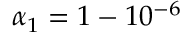<formula> <loc_0><loc_0><loc_500><loc_500>\alpha _ { 1 } = 1 - 1 0 ^ { - 6 }</formula> 